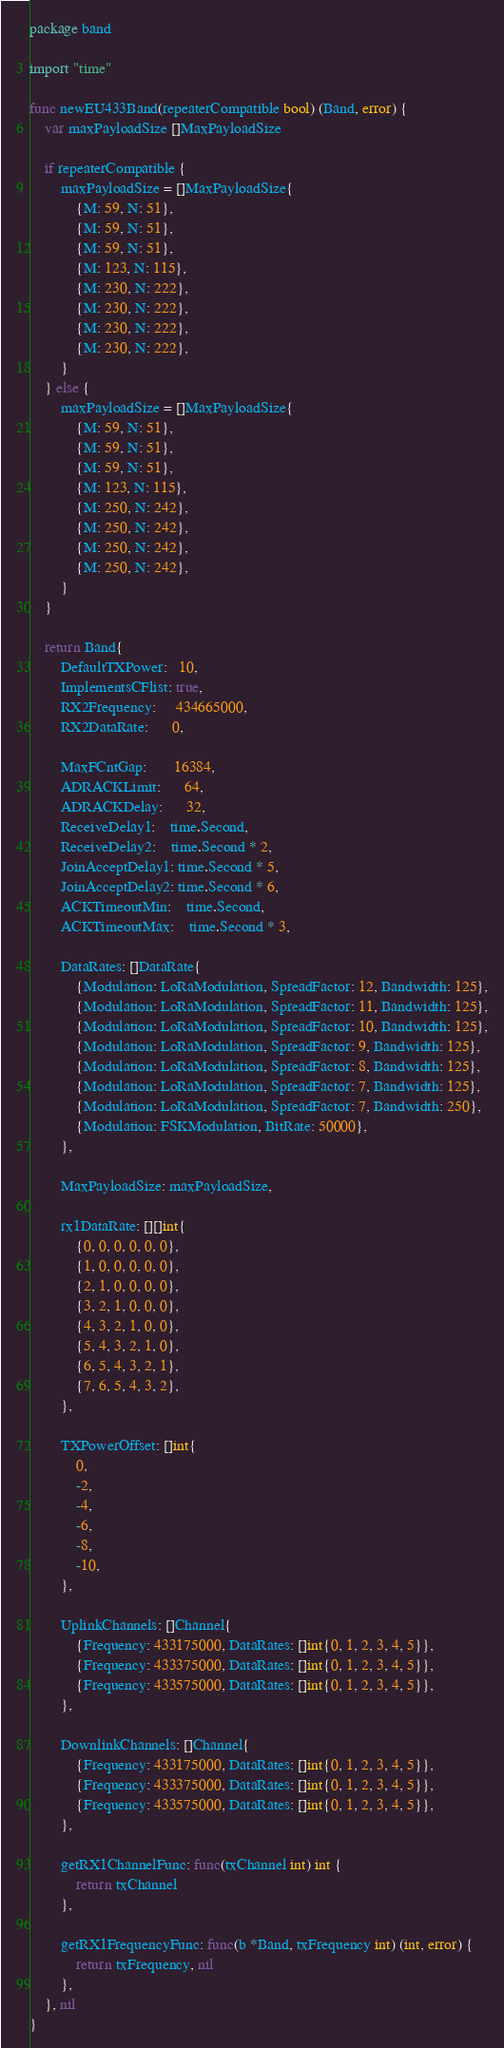Convert code to text. <code><loc_0><loc_0><loc_500><loc_500><_Go_>package band

import "time"

func newEU433Band(repeaterCompatible bool) (Band, error) {
	var maxPayloadSize []MaxPayloadSize

	if repeaterCompatible {
		maxPayloadSize = []MaxPayloadSize{
			{M: 59, N: 51},
			{M: 59, N: 51},
			{M: 59, N: 51},
			{M: 123, N: 115},
			{M: 230, N: 222},
			{M: 230, N: 222},
			{M: 230, N: 222},
			{M: 230, N: 222},
		}
	} else {
		maxPayloadSize = []MaxPayloadSize{
			{M: 59, N: 51},
			{M: 59, N: 51},
			{M: 59, N: 51},
			{M: 123, N: 115},
			{M: 250, N: 242},
			{M: 250, N: 242},
			{M: 250, N: 242},
			{M: 250, N: 242},
		}
	}

	return Band{
		DefaultTXPower:   10,
		ImplementsCFlist: true,
		RX2Frequency:     434665000,
		RX2DataRate:      0,

		MaxFCntGap:       16384,
		ADRACKLimit:      64,
		ADRACKDelay:      32,
		ReceiveDelay1:    time.Second,
		ReceiveDelay2:    time.Second * 2,
		JoinAcceptDelay1: time.Second * 5,
		JoinAcceptDelay2: time.Second * 6,
		ACKTimeoutMin:    time.Second,
		ACKTimeoutMax:    time.Second * 3,

		DataRates: []DataRate{
			{Modulation: LoRaModulation, SpreadFactor: 12, Bandwidth: 125},
			{Modulation: LoRaModulation, SpreadFactor: 11, Bandwidth: 125},
			{Modulation: LoRaModulation, SpreadFactor: 10, Bandwidth: 125},
			{Modulation: LoRaModulation, SpreadFactor: 9, Bandwidth: 125},
			{Modulation: LoRaModulation, SpreadFactor: 8, Bandwidth: 125},
			{Modulation: LoRaModulation, SpreadFactor: 7, Bandwidth: 125},
			{Modulation: LoRaModulation, SpreadFactor: 7, Bandwidth: 250},
			{Modulation: FSKModulation, BitRate: 50000},
		},

		MaxPayloadSize: maxPayloadSize,

		rx1DataRate: [][]int{
			{0, 0, 0, 0, 0, 0},
			{1, 0, 0, 0, 0, 0},
			{2, 1, 0, 0, 0, 0},
			{3, 2, 1, 0, 0, 0},
			{4, 3, 2, 1, 0, 0},
			{5, 4, 3, 2, 1, 0},
			{6, 5, 4, 3, 2, 1},
			{7, 6, 5, 4, 3, 2},
		},

		TXPowerOffset: []int{
			0,
			-2,
			-4,
			-6,
			-8,
			-10,
		},

		UplinkChannels: []Channel{
			{Frequency: 433175000, DataRates: []int{0, 1, 2, 3, 4, 5}},
			{Frequency: 433375000, DataRates: []int{0, 1, 2, 3, 4, 5}},
			{Frequency: 433575000, DataRates: []int{0, 1, 2, 3, 4, 5}},
		},

		DownlinkChannels: []Channel{
			{Frequency: 433175000, DataRates: []int{0, 1, 2, 3, 4, 5}},
			{Frequency: 433375000, DataRates: []int{0, 1, 2, 3, 4, 5}},
			{Frequency: 433575000, DataRates: []int{0, 1, 2, 3, 4, 5}},
		},

		getRX1ChannelFunc: func(txChannel int) int {
			return txChannel
		},

		getRX1FrequencyFunc: func(b *Band, txFrequency int) (int, error) {
			return txFrequency, nil
		},
	}, nil
}
</code> 